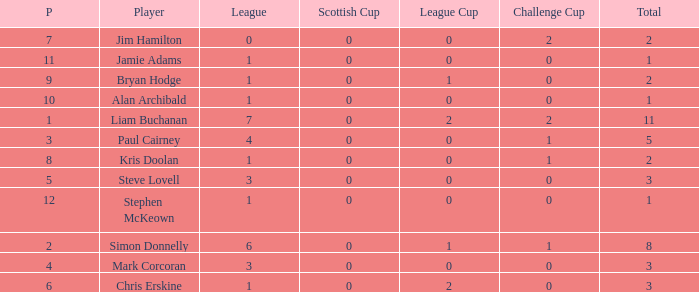How many points did player 7 score in the challenge cup? 1.0. Write the full table. {'header': ['P', 'Player', 'League', 'Scottish Cup', 'League Cup', 'Challenge Cup', 'Total'], 'rows': [['7', 'Jim Hamilton', '0', '0', '0', '2', '2'], ['11', 'Jamie Adams', '1', '0', '0', '0', '1'], ['9', 'Bryan Hodge', '1', '0', '1', '0', '2'], ['10', 'Alan Archibald', '1', '0', '0', '0', '1'], ['1', 'Liam Buchanan', '7', '0', '2', '2', '11'], ['3', 'Paul Cairney', '4', '0', '0', '1', '5'], ['8', 'Kris Doolan', '1', '0', '0', '1', '2'], ['5', 'Steve Lovell', '3', '0', '0', '0', '3'], ['12', 'Stephen McKeown', '1', '0', '0', '0', '1'], ['2', 'Simon Donnelly', '6', '0', '1', '1', '8'], ['4', 'Mark Corcoran', '3', '0', '0', '0', '3'], ['6', 'Chris Erskine', '1', '0', '2', '0', '3']]} 